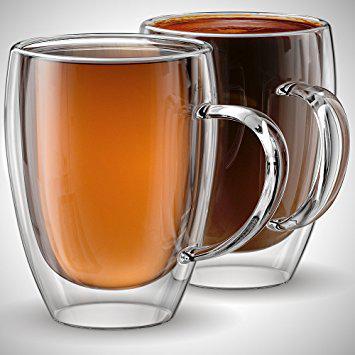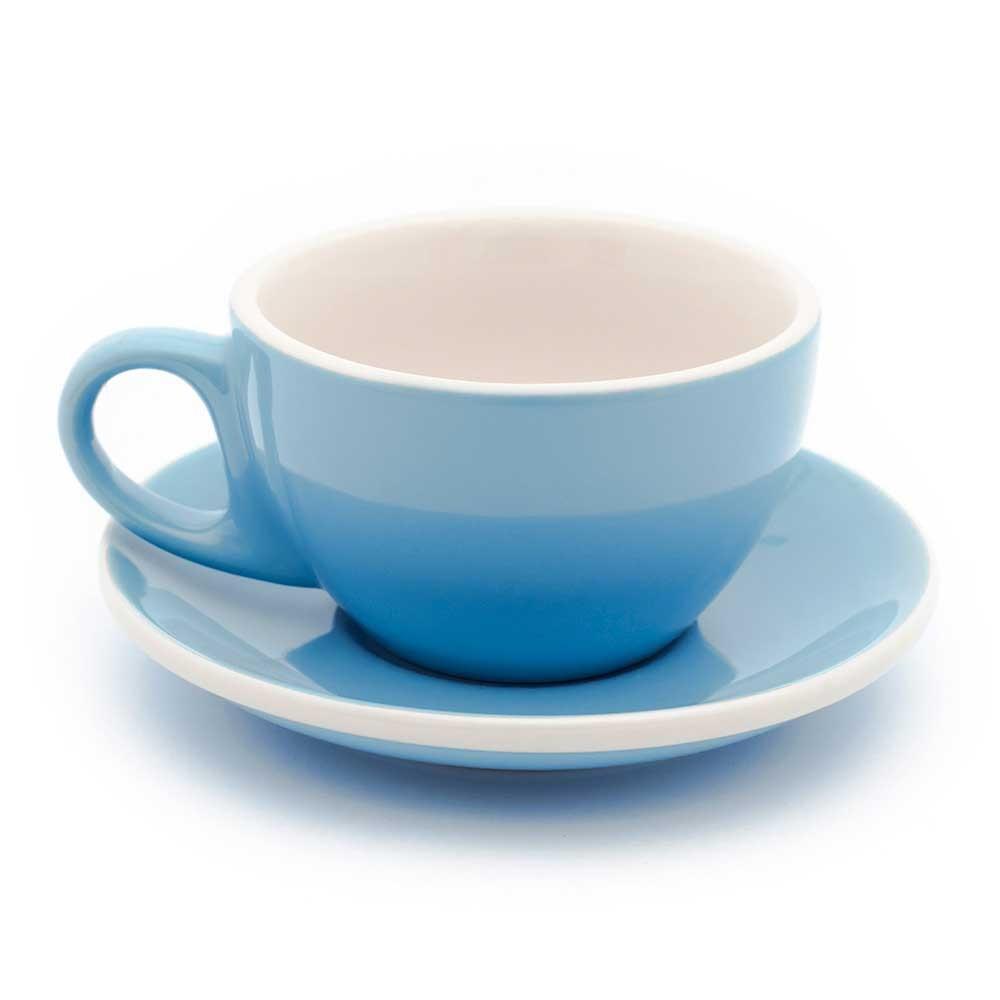The first image is the image on the left, the second image is the image on the right. Considering the images on both sides, is "There is a milk design in a coffee." valid? Answer yes or no. No. 